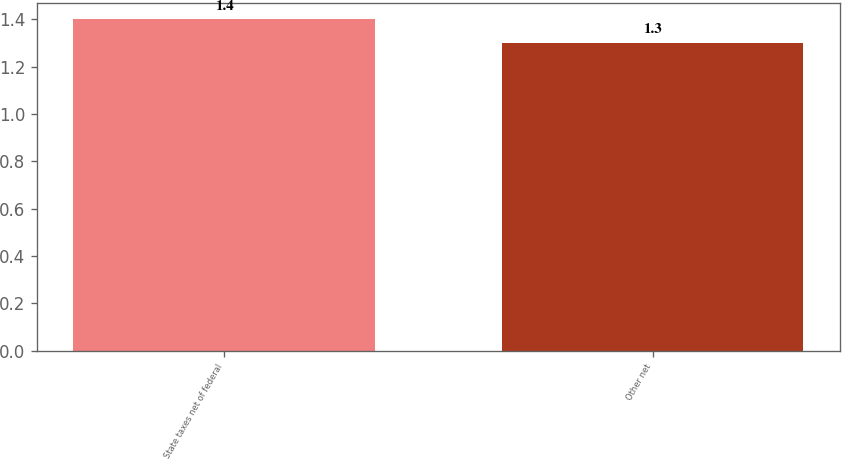Convert chart. <chart><loc_0><loc_0><loc_500><loc_500><bar_chart><fcel>State taxes net of federal<fcel>Other net<nl><fcel>1.4<fcel>1.3<nl></chart> 